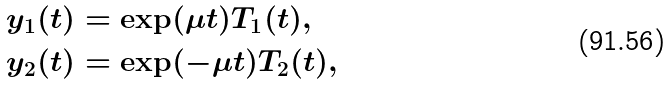<formula> <loc_0><loc_0><loc_500><loc_500>y _ { 1 } ( t ) & = \exp ( \mu t ) T _ { 1 } ( t ) , \\ y _ { 2 } ( t ) & = \exp ( - \mu t ) T _ { 2 } ( t ) ,</formula> 